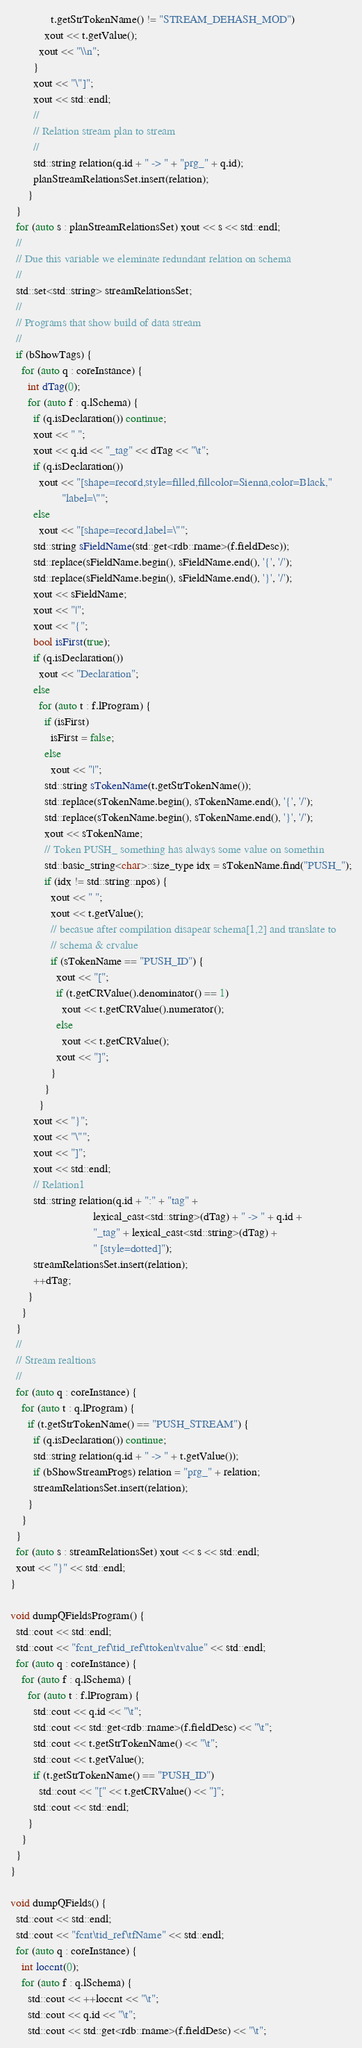<code> <loc_0><loc_0><loc_500><loc_500><_C++_>              t.getStrTokenName() != "STREAM_DEHASH_MOD")
            xout << t.getValue();
          xout << "\\n";
        }
        xout << "\"]";
        xout << std::endl;
        //
        // Relation stream plan to stream
        //
        std::string relation(q.id + " -> " + "prg_" + q.id);
        planStreamRelationsSet.insert(relation);
      }
  }
  for (auto s : planStreamRelationsSet) xout << s << std::endl;
  //
  // Due this variable we eleminate redundant relation on schema
  //
  std::set<std::string> streamRelationsSet;
  //
  // Programs that show build of data stream
  //
  if (bShowTags) {
    for (auto q : coreInstance) {
      int dTag(0);
      for (auto f : q.lSchema) {
        if (q.isDeclaration()) continue;
        xout << " ";
        xout << q.id << "_tag" << dTag << "\t";
        if (q.isDeclaration())
          xout << "[shape=record,style=filled,fillcolor=Sienna,color=Black,"
                  "label=\"";
        else
          xout << "[shape=record,label=\"";
        std::string sFieldName(std::get<rdb::rname>(f.fieldDesc));
        std::replace(sFieldName.begin(), sFieldName.end(), '{', '/');
        std::replace(sFieldName.begin(), sFieldName.end(), '}', '/');
        xout << sFieldName;
        xout << "|";
        xout << "{";
        bool isFirst(true);
        if (q.isDeclaration())
          xout << "Declaration";
        else
          for (auto t : f.lProgram) {
            if (isFirst)
              isFirst = false;
            else
              xout << "|";
            std::string sTokenName(t.getStrTokenName());
            std::replace(sTokenName.begin(), sTokenName.end(), '{', '/');
            std::replace(sTokenName.begin(), sTokenName.end(), '}', '/');
            xout << sTokenName;
            // Token PUSH_ something has always some value on somethin
            std::basic_string<char>::size_type idx = sTokenName.find("PUSH_");
            if (idx != std::string::npos) {
              xout << " ";
              xout << t.getValue();
              // becasue after compilation disapear schema[1,2] and translate to
              // schema & crvalue
              if (sTokenName == "PUSH_ID") {
                xout << "[";
                if (t.getCRValue().denominator() == 1)
                  xout << t.getCRValue().numerator();
                else
                  xout << t.getCRValue();
                xout << "]";
              }
            }
          }
        xout << "}";
        xout << "\"";
        xout << "]";
        xout << std::endl;
        // Relation1
        std::string relation(q.id + ":" + "tag" +
                             lexical_cast<std::string>(dTag) + " -> " + q.id +
                             "_tag" + lexical_cast<std::string>(dTag) +
                             " [style=dotted]");
        streamRelationsSet.insert(relation);
        ++dTag;
      }
    }
  }
  //
  // Stream realtions
  //
  for (auto q : coreInstance) {
    for (auto t : q.lProgram) {
      if (t.getStrTokenName() == "PUSH_STREAM") {
        if (q.isDeclaration()) continue;
        std::string relation(q.id + " -> " + t.getValue());
        if (bShowStreamProgs) relation = "prg_" + relation;
        streamRelationsSet.insert(relation);
      }
    }
  }
  for (auto s : streamRelationsSet) xout << s << std::endl;
  xout << "}" << std::endl;
}

void dumpQFieldsProgram() {
  std::cout << std::endl;
  std::cout << "fcnt_ref\tid_ref\ttoken\tvalue" << std::endl;
  for (auto q : coreInstance) {
    for (auto f : q.lSchema) {
      for (auto t : f.lProgram) {
        std::cout << q.id << "\t";
        std::cout << std::get<rdb::rname>(f.fieldDesc) << "\t";
        std::cout << t.getStrTokenName() << "\t";
        std::cout << t.getValue();
        if (t.getStrTokenName() == "PUSH_ID")
          std::cout << "[" << t.getCRValue() << "]";
        std::cout << std::endl;
      }
    }
  }
}

void dumpQFields() {
  std::cout << std::endl;
  std::cout << "fcnt\tid_ref\tfName" << std::endl;
  for (auto q : coreInstance) {
    int loccnt(0);
    for (auto f : q.lSchema) {
      std::cout << ++loccnt << "\t";
      std::cout << q.id << "\t";
      std::cout << std::get<rdb::rname>(f.fieldDesc) << "\t";</code> 